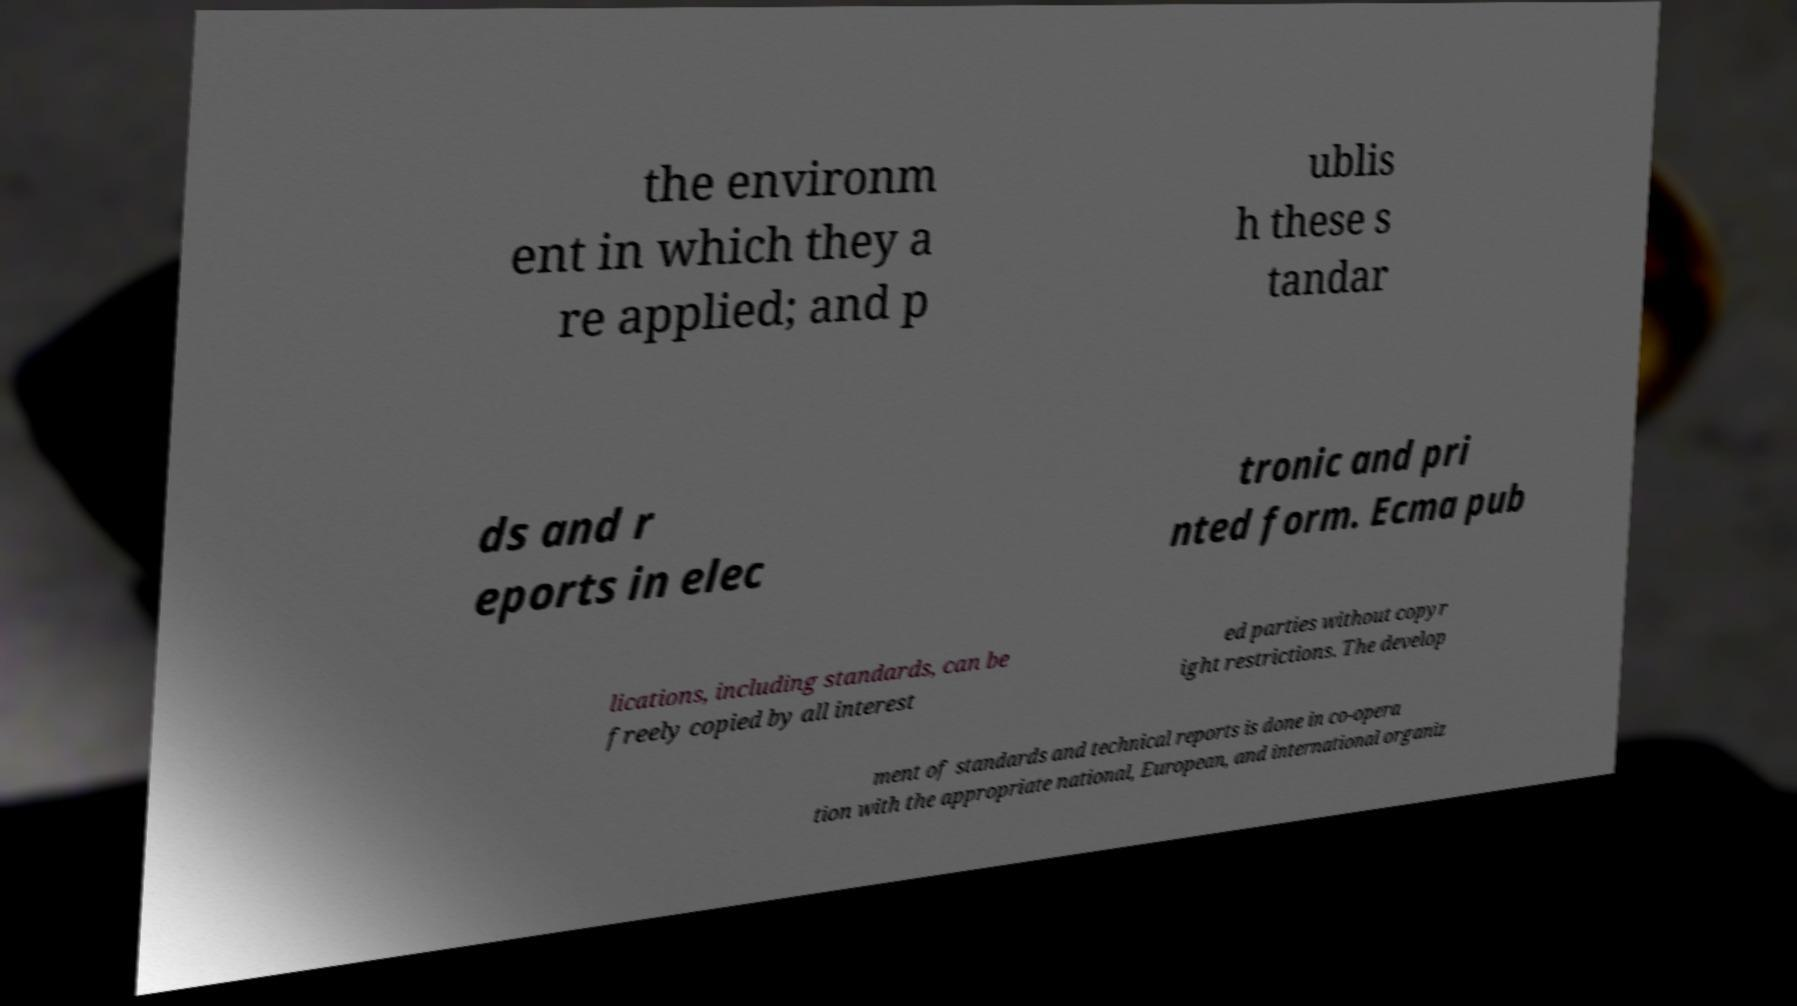Please read and relay the text visible in this image. What does it say? the environm ent in which they a re applied; and p ublis h these s tandar ds and r eports in elec tronic and pri nted form. Ecma pub lications, including standards, can be freely copied by all interest ed parties without copyr ight restrictions. The develop ment of standards and technical reports is done in co-opera tion with the appropriate national, European, and international organiz 